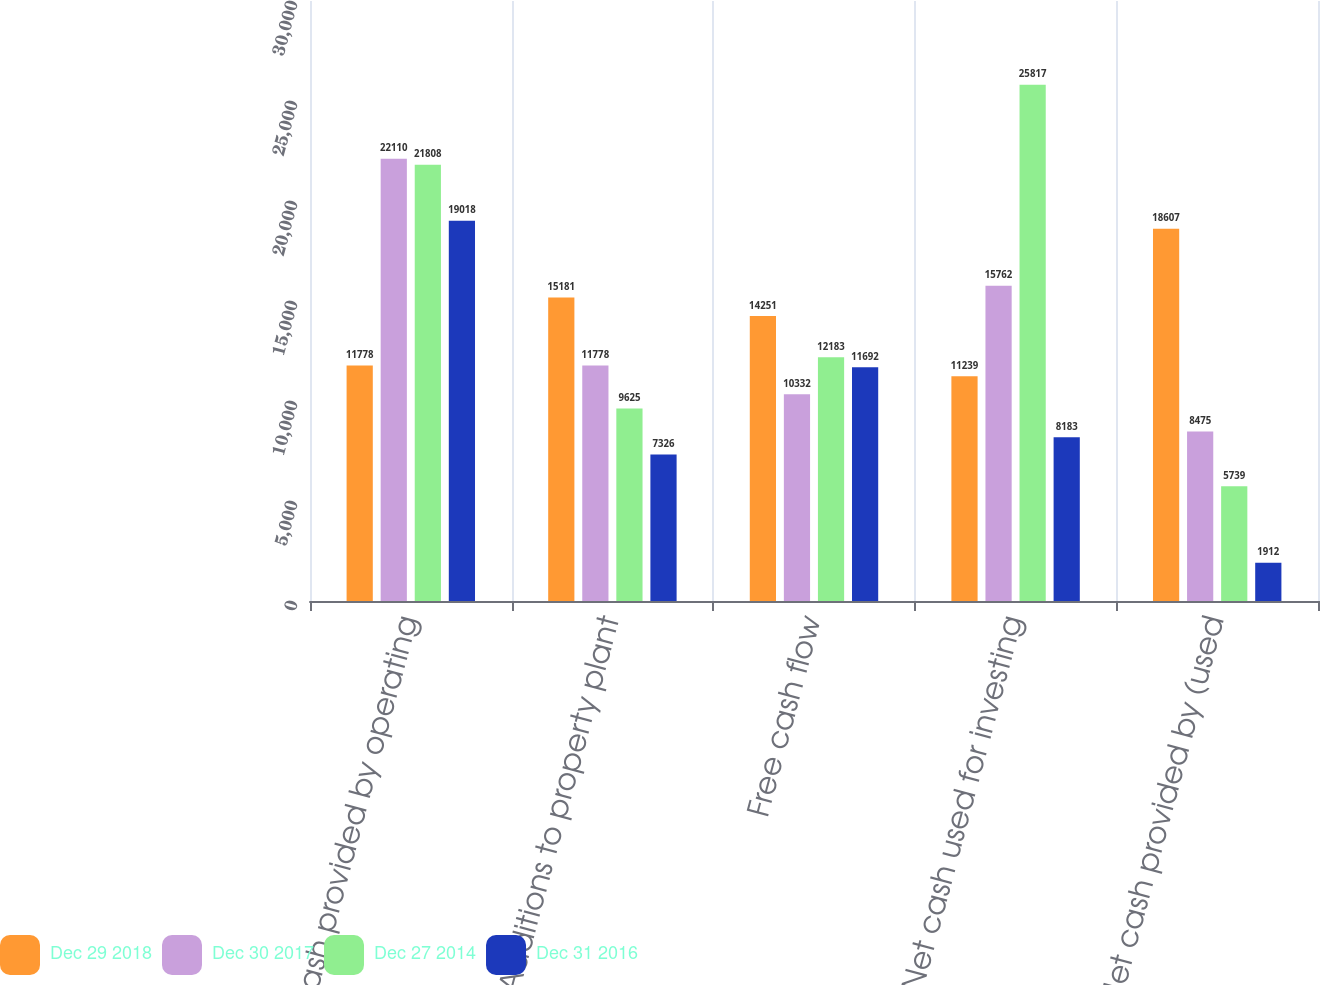Convert chart. <chart><loc_0><loc_0><loc_500><loc_500><stacked_bar_chart><ecel><fcel>Net cash provided by operating<fcel>Additions to property plant<fcel>Free cash flow<fcel>Net cash used for investing<fcel>Net cash provided by (used<nl><fcel>Dec 29 2018<fcel>11778<fcel>15181<fcel>14251<fcel>11239<fcel>18607<nl><fcel>Dec 30 2017<fcel>22110<fcel>11778<fcel>10332<fcel>15762<fcel>8475<nl><fcel>Dec 27 2014<fcel>21808<fcel>9625<fcel>12183<fcel>25817<fcel>5739<nl><fcel>Dec 31 2016<fcel>19018<fcel>7326<fcel>11692<fcel>8183<fcel>1912<nl></chart> 